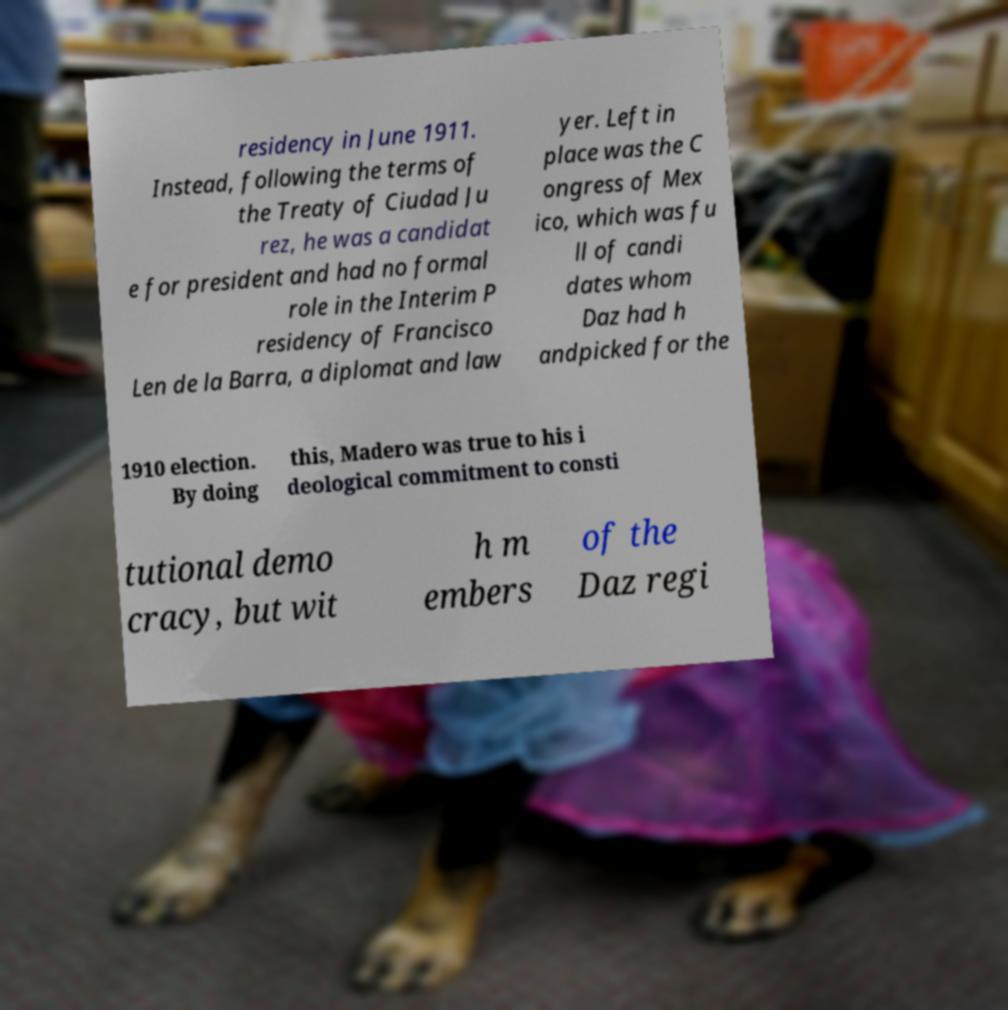Can you accurately transcribe the text from the provided image for me? residency in June 1911. Instead, following the terms of the Treaty of Ciudad Ju rez, he was a candidat e for president and had no formal role in the Interim P residency of Francisco Len de la Barra, a diplomat and law yer. Left in place was the C ongress of Mex ico, which was fu ll of candi dates whom Daz had h andpicked for the 1910 election. By doing this, Madero was true to his i deological commitment to consti tutional demo cracy, but wit h m embers of the Daz regi 